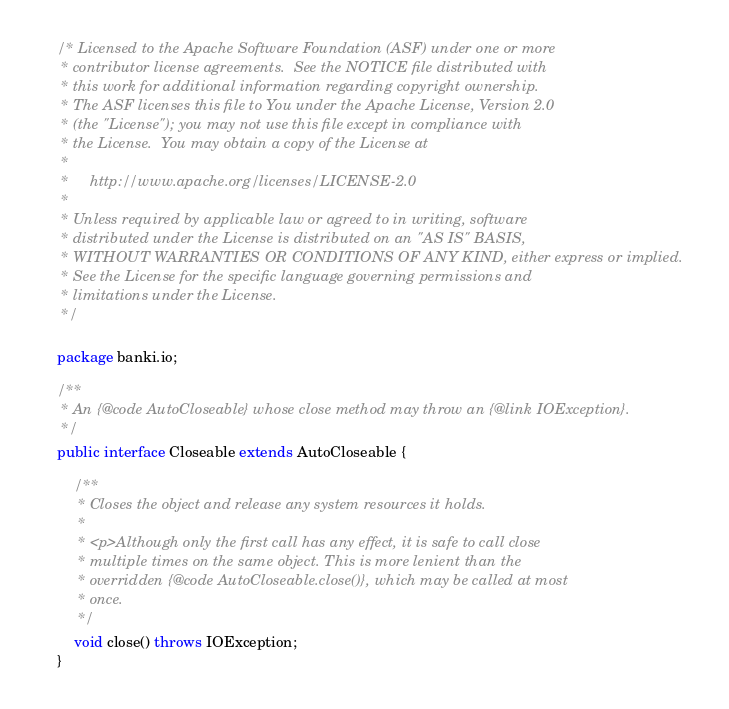<code> <loc_0><loc_0><loc_500><loc_500><_Java_>/* Licensed to the Apache Software Foundation (ASF) under one or more
 * contributor license agreements.  See the NOTICE file distributed with
 * this work for additional information regarding copyright ownership.
 * The ASF licenses this file to You under the Apache License, Version 2.0
 * (the "License"); you may not use this file except in compliance with
 * the License.  You may obtain a copy of the License at
 *
 *     http://www.apache.org/licenses/LICENSE-2.0
 *
 * Unless required by applicable law or agreed to in writing, software
 * distributed under the License is distributed on an "AS IS" BASIS,
 * WITHOUT WARRANTIES OR CONDITIONS OF ANY KIND, either express or implied.
 * See the License for the specific language governing permissions and
 * limitations under the License.
 */

package banki.io;

/**
 * An {@code AutoCloseable} whose close method may throw an {@link IOException}.
 */
public interface Closeable extends AutoCloseable {

    /**
     * Closes the object and release any system resources it holds.
     *
     * <p>Although only the first call has any effect, it is safe to call close
     * multiple times on the same object. This is more lenient than the
     * overridden {@code AutoCloseable.close()}, which may be called at most
     * once.
     */
    void close() throws IOException;
}
</code> 